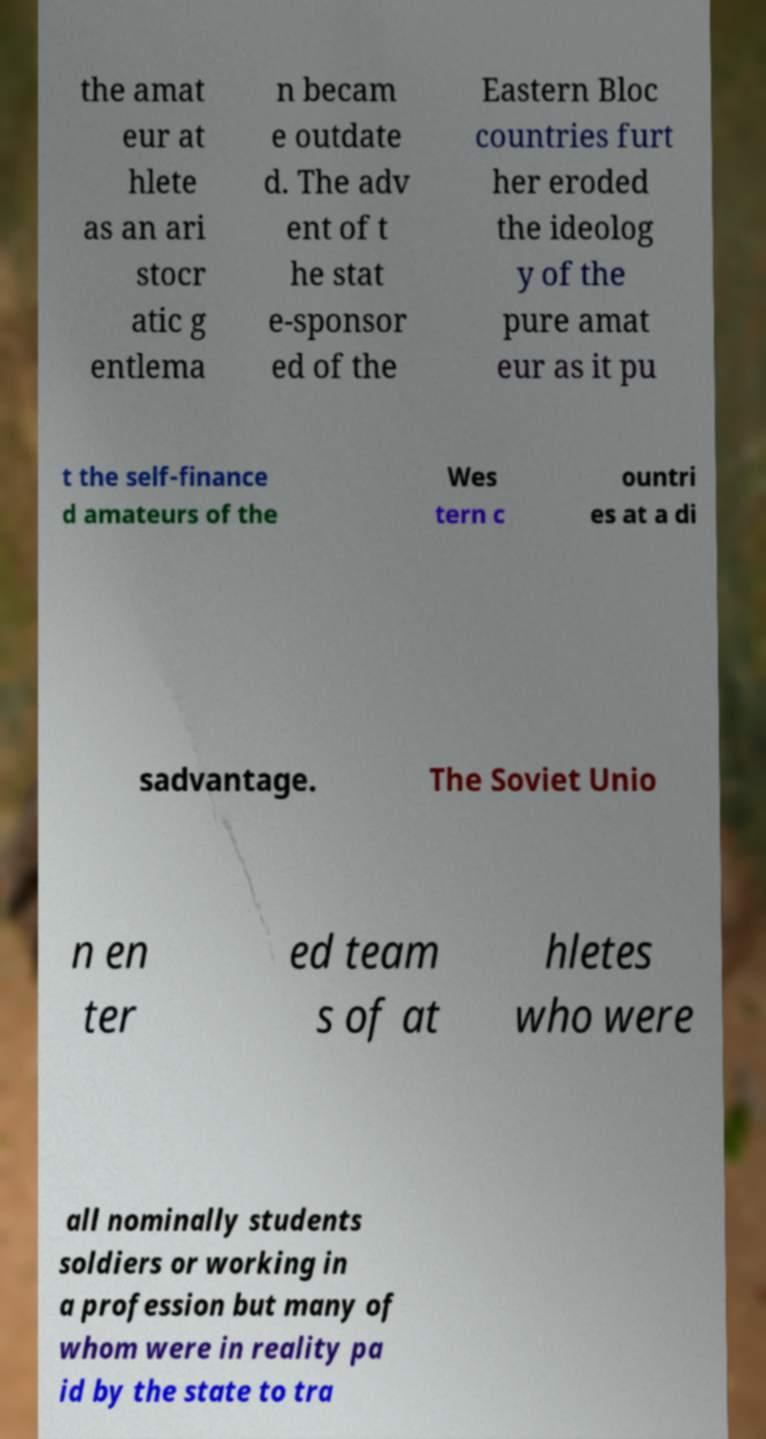I need the written content from this picture converted into text. Can you do that? the amat eur at hlete as an ari stocr atic g entlema n becam e outdate d. The adv ent of t he stat e-sponsor ed of the Eastern Bloc countries furt her eroded the ideolog y of the pure amat eur as it pu t the self-finance d amateurs of the Wes tern c ountri es at a di sadvantage. The Soviet Unio n en ter ed team s of at hletes who were all nominally students soldiers or working in a profession but many of whom were in reality pa id by the state to tra 